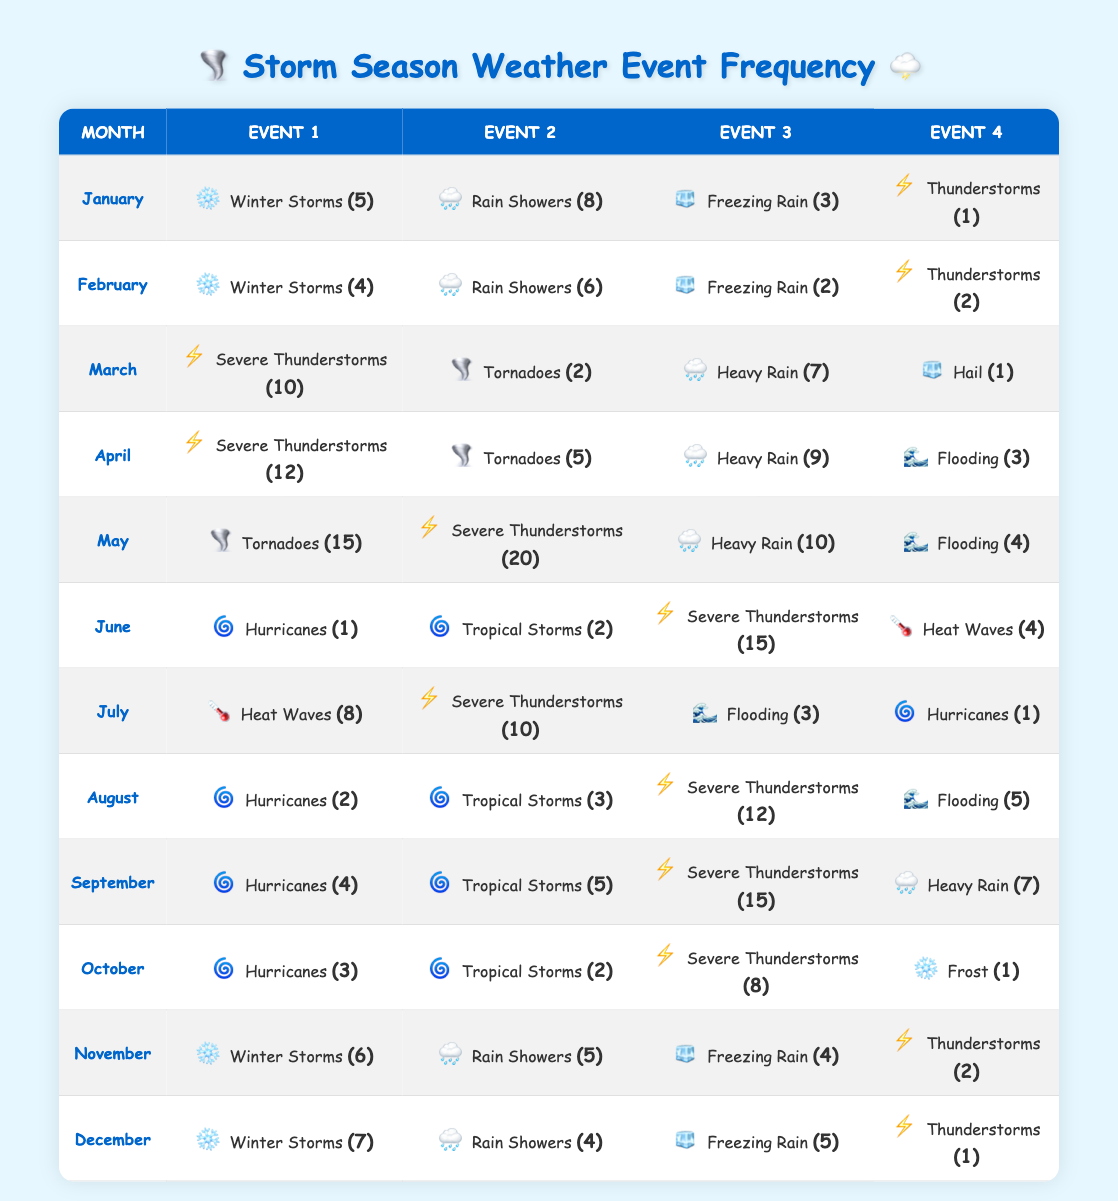What is the most frequent type of weather event in May? In May, the events listed are Tornadoes (15), Severe Thunderstorms (20), Heavy Rain (10), and Flooding (4). The highest frequency is 20 for Severe Thunderstorms.
Answer: Severe Thunderstorms How many Severe Thunderstorms occurred in April and May combined? In April, there are 12 Severe Thunderstorms, and in May, there are 20. Adding these together: 12 + 20 = 32.
Answer: 32 Did June have more Severe Thunderstorms or Heat Waves? In June, there are 15 Severe Thunderstorms and 4 Heat Waves. Since 15 is greater than 4, June had more Severe Thunderstorms.
Answer: Yes What is the total count of Hurricane events across all months? The data shows Hurricanes occurred in June (1), July (1), August (2), September (4), and October (3). Adding these: 1 + 1 + 2 + 4 + 3 = 11.
Answer: 11 Which month has the highest frequency of Tornadoes? Tornadoes occurred in March (2), April (5), and May (15). May has the highest frequency at 15.
Answer: May What is the average number of Flooding events from April to August? The Flooding events are: April (3), May (4), June (0), July (3), and August (5). To find the average, first calculate the total: 3 + 4 + 0 + 3 + 5 = 15. Then divide by the number of months (5): 15 / 5 = 3.
Answer: 3 Is there a month where Freezing Rain did not occur? Freezing Rain events are recorded only in January (3), February (2), November (4), and December (5). There are no recorded Freezing Rain events in March, April, May, June, July, August, September, or October.
Answer: Yes Which month has the least number of Thunderstorm events? Checking the Thunderstorm occurrences: January (1), February (2), March (10), April (0), May (0), July (10), August (12), September (15), October (8), November (2), December (1). The month with the least events is January with 1.
Answer: January In which month did Heavy Rain occur the most, and how many times? The months with Heavy Rain are March (7), April (9), May (10), September (7). May has the highest occurrence at 10.
Answer: May, 10 